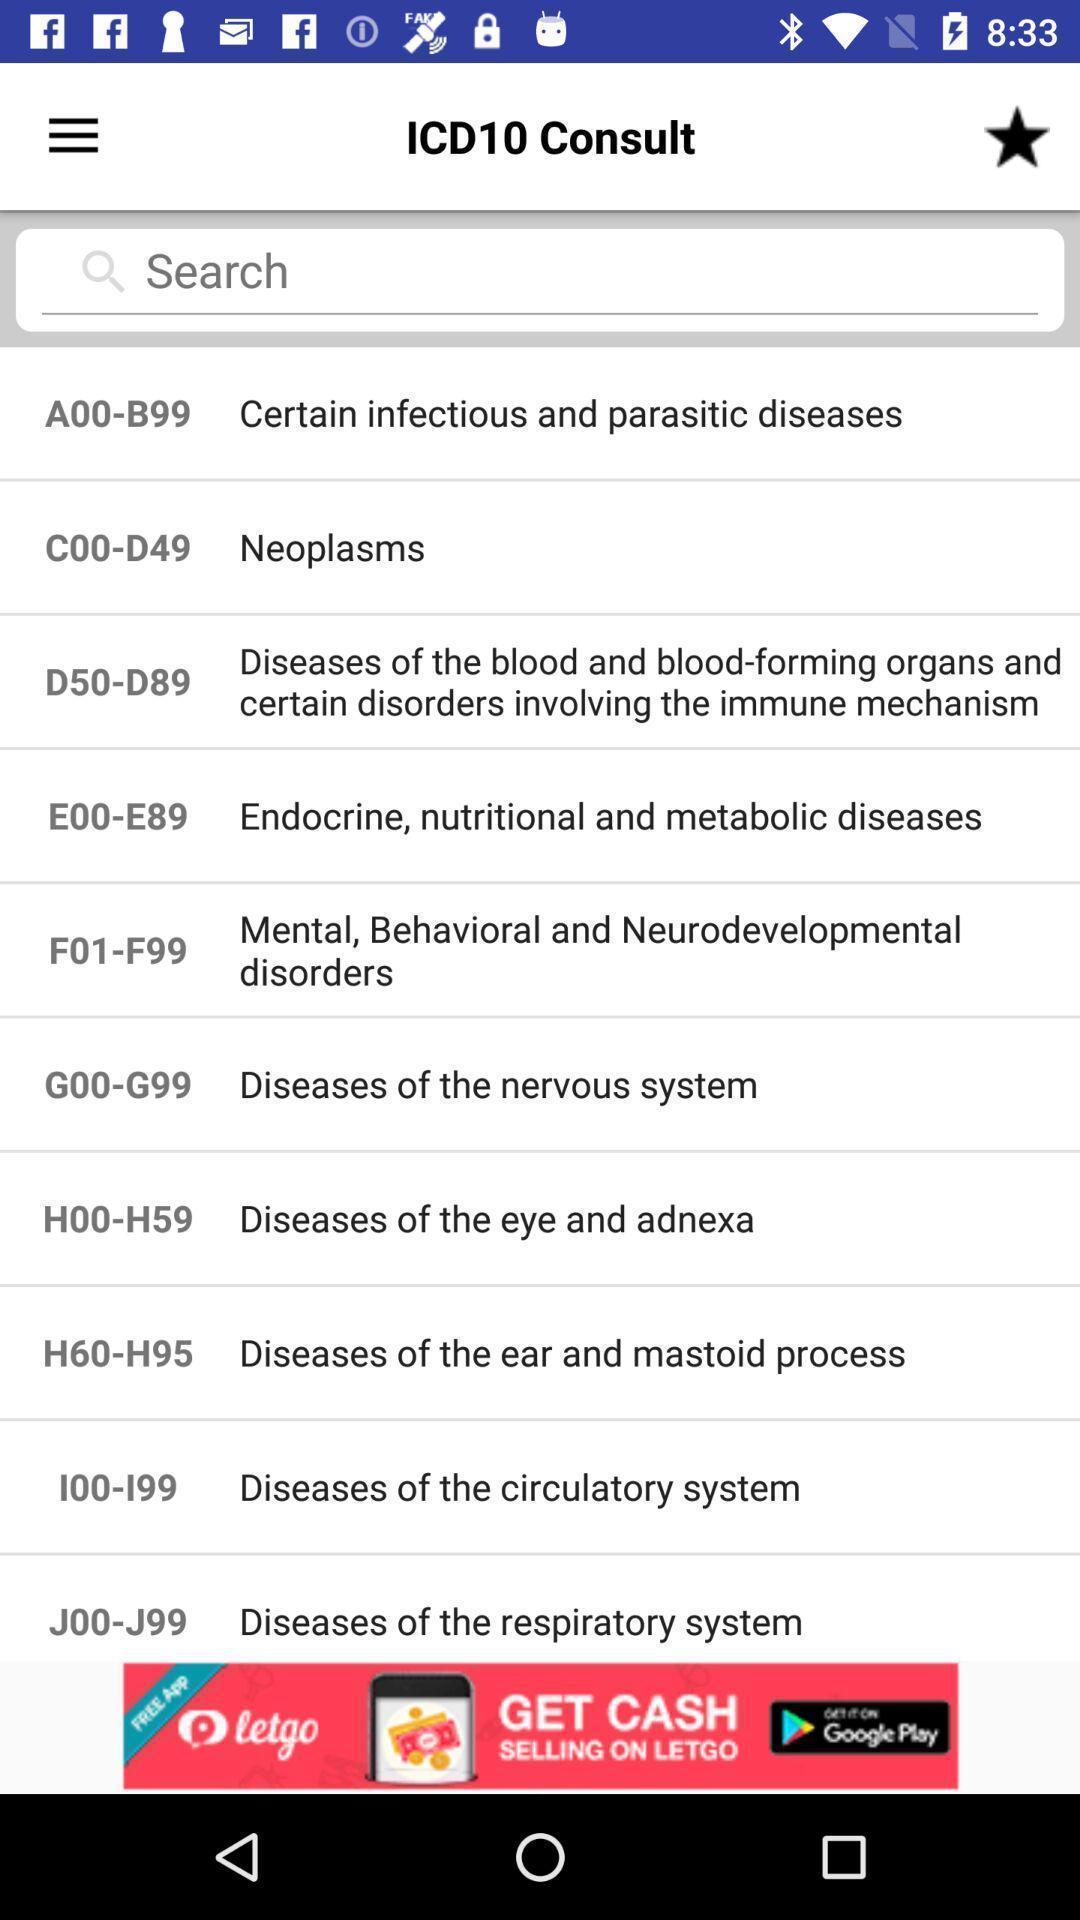Describe the content in this image. List of topics in education app. 